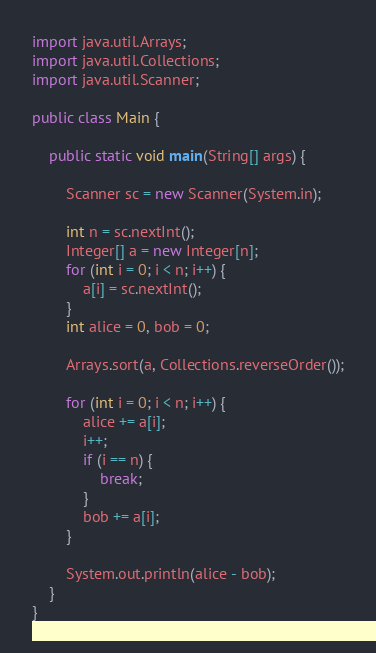<code> <loc_0><loc_0><loc_500><loc_500><_Java_>import java.util.Arrays;
import java.util.Collections;
import java.util.Scanner;

public class Main {

	public static void main(String[] args) {

		Scanner sc = new Scanner(System.in);

		int n = sc.nextInt();
		Integer[] a = new Integer[n];
		for (int i = 0; i < n; i++) {
			a[i] = sc.nextInt();
		}
		int alice = 0, bob = 0;

		Arrays.sort(a, Collections.reverseOrder());

		for (int i = 0; i < n; i++) {
			alice += a[i];
			i++;
			if (i == n) {
				break;
			}
			bob += a[i];
		}

		System.out.println(alice - bob);
	}
}</code> 